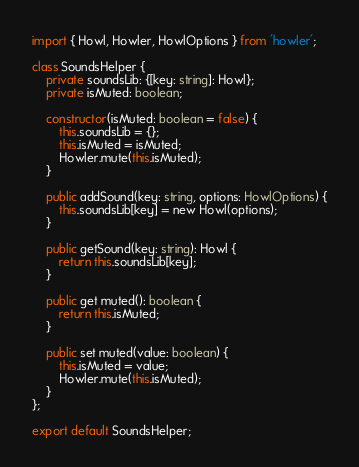Convert code to text. <code><loc_0><loc_0><loc_500><loc_500><_TypeScript_>import { Howl, Howler, HowlOptions } from 'howler';

class SoundsHelper {
    private soundsLib: {[key: string]: Howl};
    private isMuted: boolean;

    constructor(isMuted: boolean = false) {
        this.soundsLib = {};
        this.isMuted = isMuted;
        Howler.mute(this.isMuted);
    }

    public addSound(key: string, options: HowlOptions) {
        this.soundsLib[key] = new Howl(options);
    }

    public getSound(key: string): Howl {
        return this.soundsLib[key];
    }

    public get muted(): boolean {
        return this.isMuted;
    }

    public set muted(value: boolean) {
        this.isMuted = value;
        Howler.mute(this.isMuted);
    }
};

export default SoundsHelper;</code> 